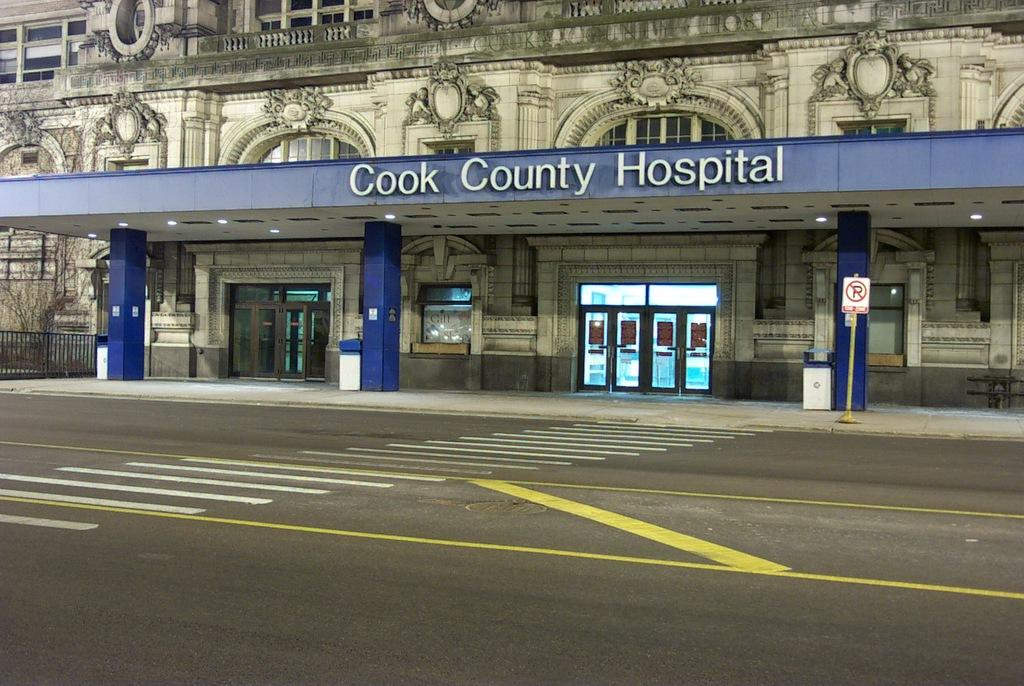<image>
Describe the image concisely. the word hospital is on the blue sign outside 